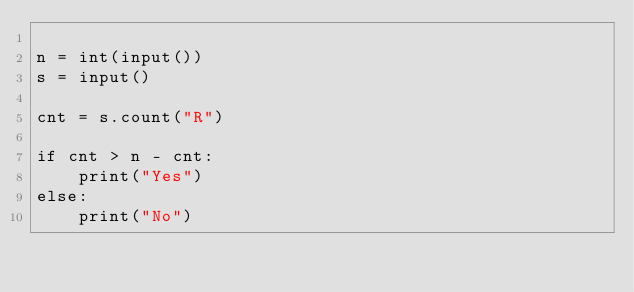<code> <loc_0><loc_0><loc_500><loc_500><_Python_>
n = int(input())
s = input()

cnt = s.count("R")

if cnt > n - cnt:
    print("Yes")
else:
    print("No")</code> 